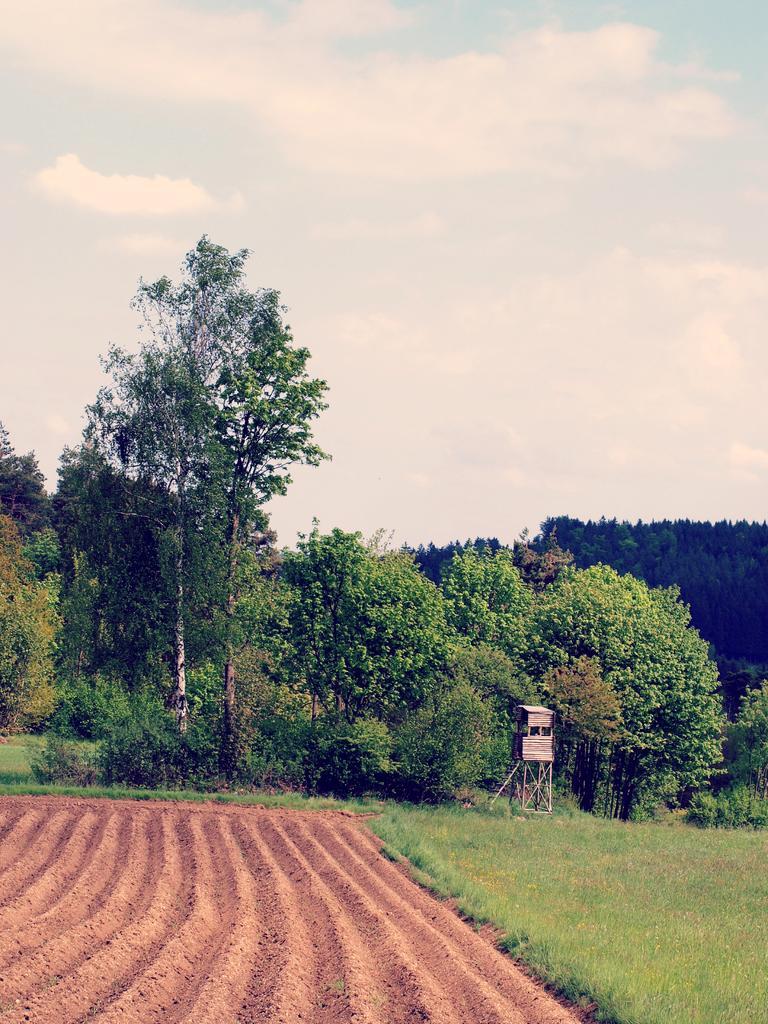Could you give a brief overview of what you see in this image? This picture shows a cloudy sky and few trees 